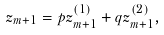Convert formula to latex. <formula><loc_0><loc_0><loc_500><loc_500>z _ { m + 1 } = p z _ { m + 1 } ^ { ( 1 ) } + q z _ { m + 1 } ^ { ( 2 ) } ,</formula> 